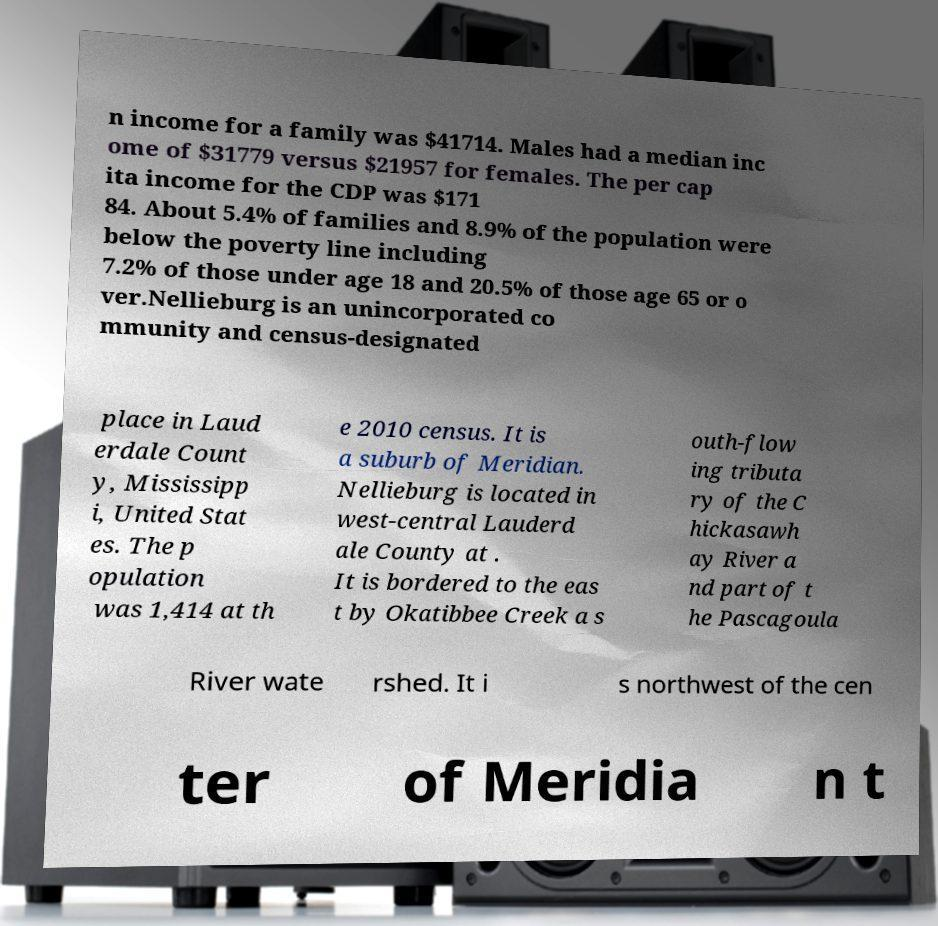For documentation purposes, I need the text within this image transcribed. Could you provide that? n income for a family was $41714. Males had a median inc ome of $31779 versus $21957 for females. The per cap ita income for the CDP was $171 84. About 5.4% of families and 8.9% of the population were below the poverty line including 7.2% of those under age 18 and 20.5% of those age 65 or o ver.Nellieburg is an unincorporated co mmunity and census-designated place in Laud erdale Count y, Mississipp i, United Stat es. The p opulation was 1,414 at th e 2010 census. It is a suburb of Meridian. Nellieburg is located in west-central Lauderd ale County at . It is bordered to the eas t by Okatibbee Creek a s outh-flow ing tributa ry of the C hickasawh ay River a nd part of t he Pascagoula River wate rshed. It i s northwest of the cen ter of Meridia n t 